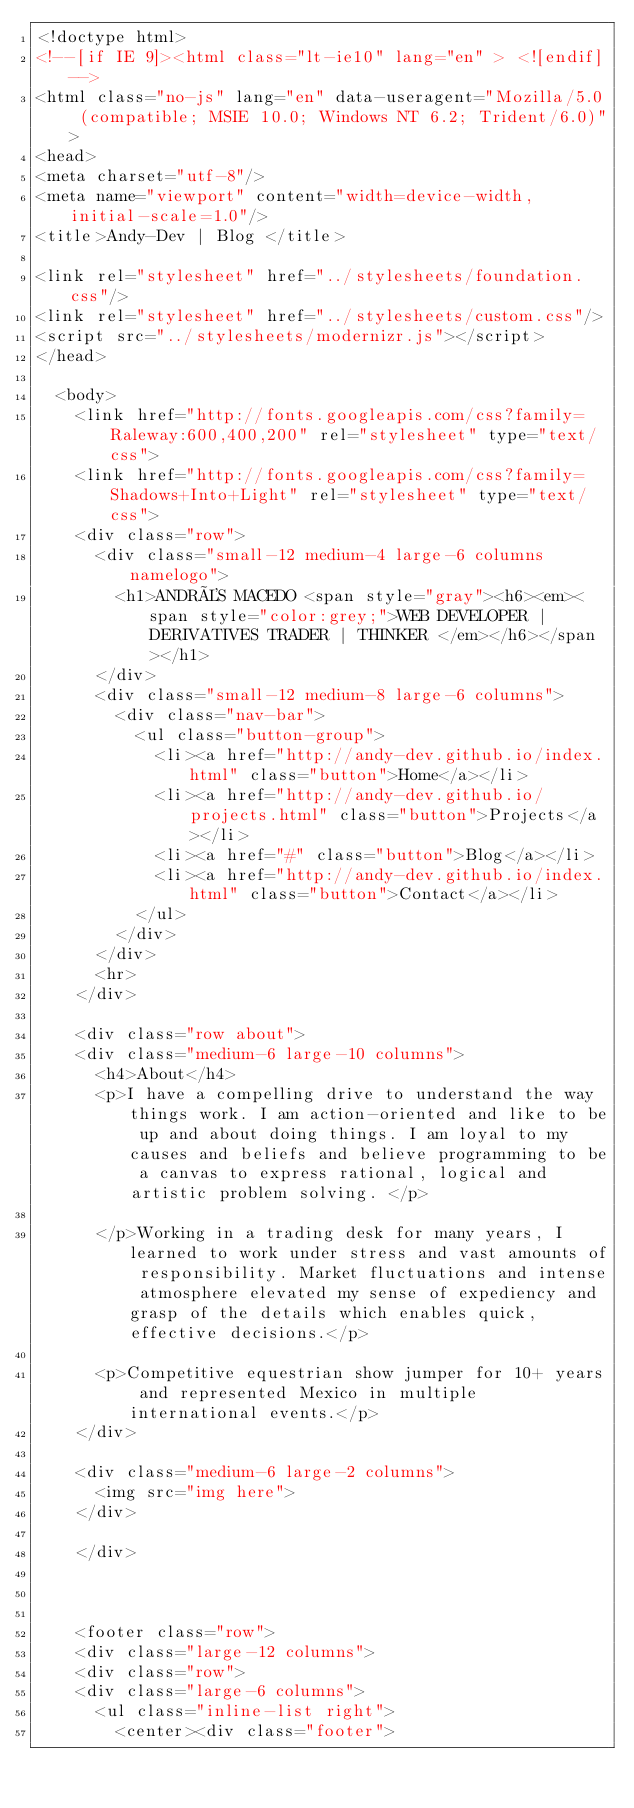Convert code to text. <code><loc_0><loc_0><loc_500><loc_500><_HTML_><!doctype html>
<!--[if IE 9]><html class="lt-ie10" lang="en" > <![endif]-->
<html class="no-js" lang="en" data-useragent="Mozilla/5.0 (compatible; MSIE 10.0; Windows NT 6.2; Trident/6.0)">
<head>
<meta charset="utf-8"/>
<meta name="viewport" content="width=device-width, initial-scale=1.0"/>
<title>Andy-Dev | Blog </title>

<link rel="stylesheet" href="../stylesheets/foundation.css"/>
<link rel="stylesheet" href="../stylesheets/custom.css"/>
<script src="../stylesheets/modernizr.js"></script>
</head>

  <body>
    <link href="http://fonts.googleapis.com/css?family=Raleway:600,400,200" rel="stylesheet" type="text/css">
    <link href="http://fonts.googleapis.com/css?family=Shadows+Into+Light" rel="stylesheet" type="text/css">
    <div class="row">
      <div class="small-12 medium-4 large-6 columns namelogo">
        <h1>ANDRÉS MACEDO <span style="gray"><h6><em><span style="color:grey;">WEB DEVELOPER | DERIVATIVES TRADER | THINKER </em></h6></span></h1>
      </div>
      <div class="small-12 medium-8 large-6 columns">
        <div class="nav-bar">
          <ul class="button-group">
            <li><a href="http://andy-dev.github.io/index.html" class="button">Home</a></li>
            <li><a href="http://andy-dev.github.io/projects.html" class="button">Projects</a></li>
            <li><a href="#" class="button">Blog</a></li>
            <li><a href="http://andy-dev.github.io/index.html" class="button">Contact</a></li>
          </ul>
        </div>
      </div>
      <hr>
    </div>

    <div class="row about">
    <div class="medium-6 large-10 columns">
      <h4>About</h4>
      <p>I have a compelling drive to understand the way things work. I am action-oriented and like to be up and about doing things. I am loyal to my causes and beliefs and believe programming to be a canvas to express rational, logical and artistic problem solving. </p>

      </p>Working in a trading desk for many years, I learned to work under stress and vast amounts of responsibility. Market fluctuations and intense atmosphere elevated my sense of expediency and grasp of the details which enables quick, effective decisions.</p>

      <p>Competitive equestrian show jumper for 10+ years and represented Mexico in multiple international events.</p>
    </div>

    <div class="medium-6 large-2 columns">
      <img src="img here">
    </div>

    </div>



    <footer class="row">
    <div class="large-12 columns">
    <div class="row">
    <div class="large-6 columns">
      <ul class="inline-list right">
        <center><div class="footer"></code> 